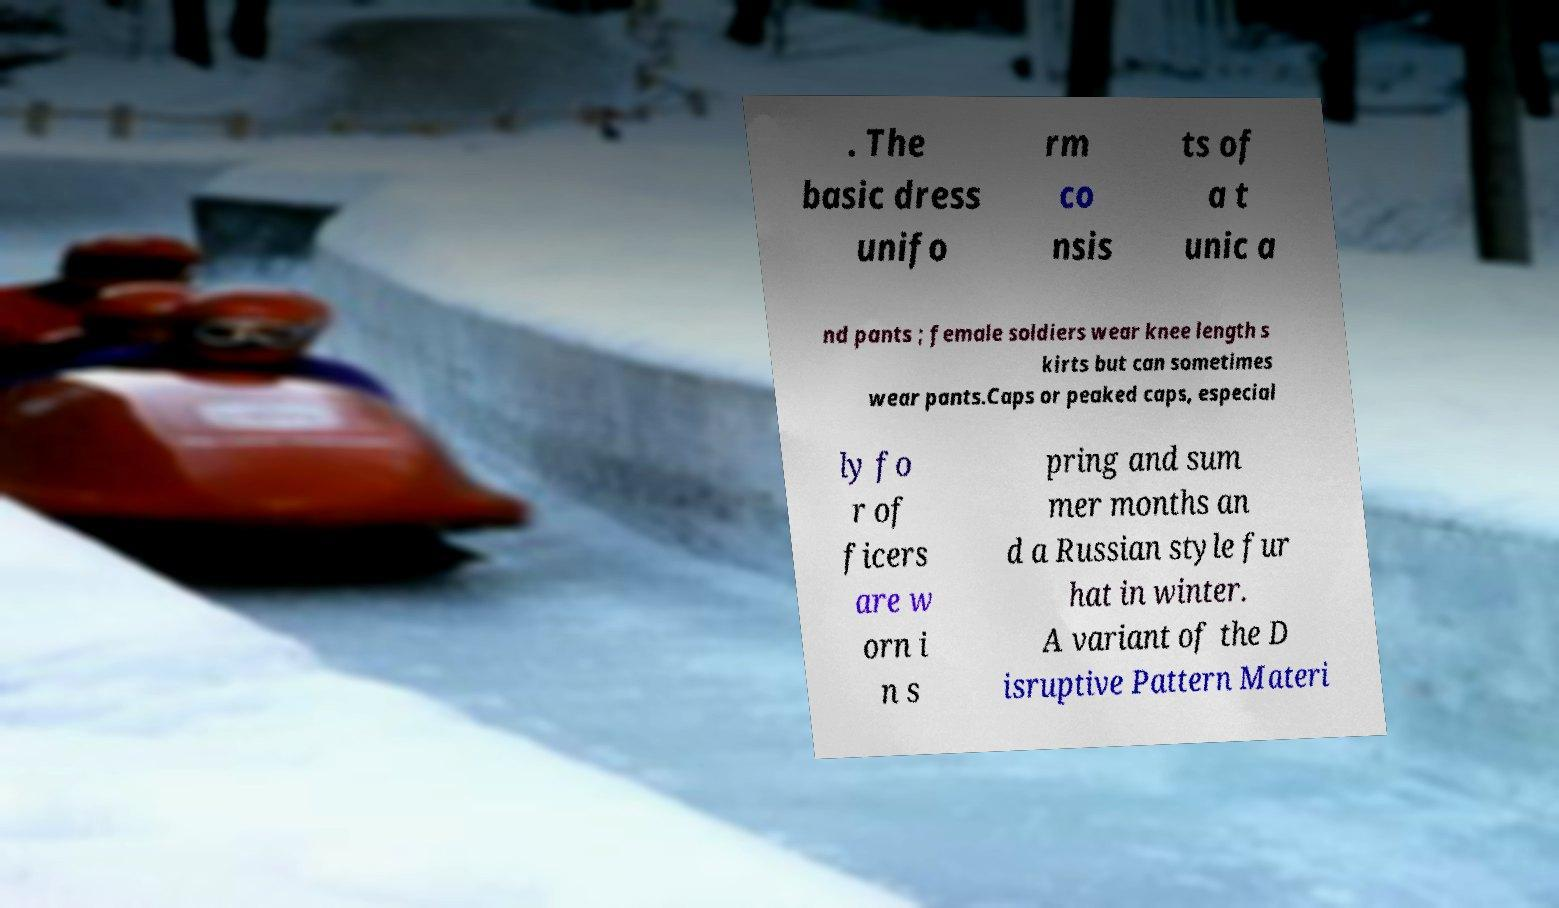There's text embedded in this image that I need extracted. Can you transcribe it verbatim? . The basic dress unifo rm co nsis ts of a t unic a nd pants ; female soldiers wear knee length s kirts but can sometimes wear pants.Caps or peaked caps, especial ly fo r of ficers are w orn i n s pring and sum mer months an d a Russian style fur hat in winter. A variant of the D isruptive Pattern Materi 